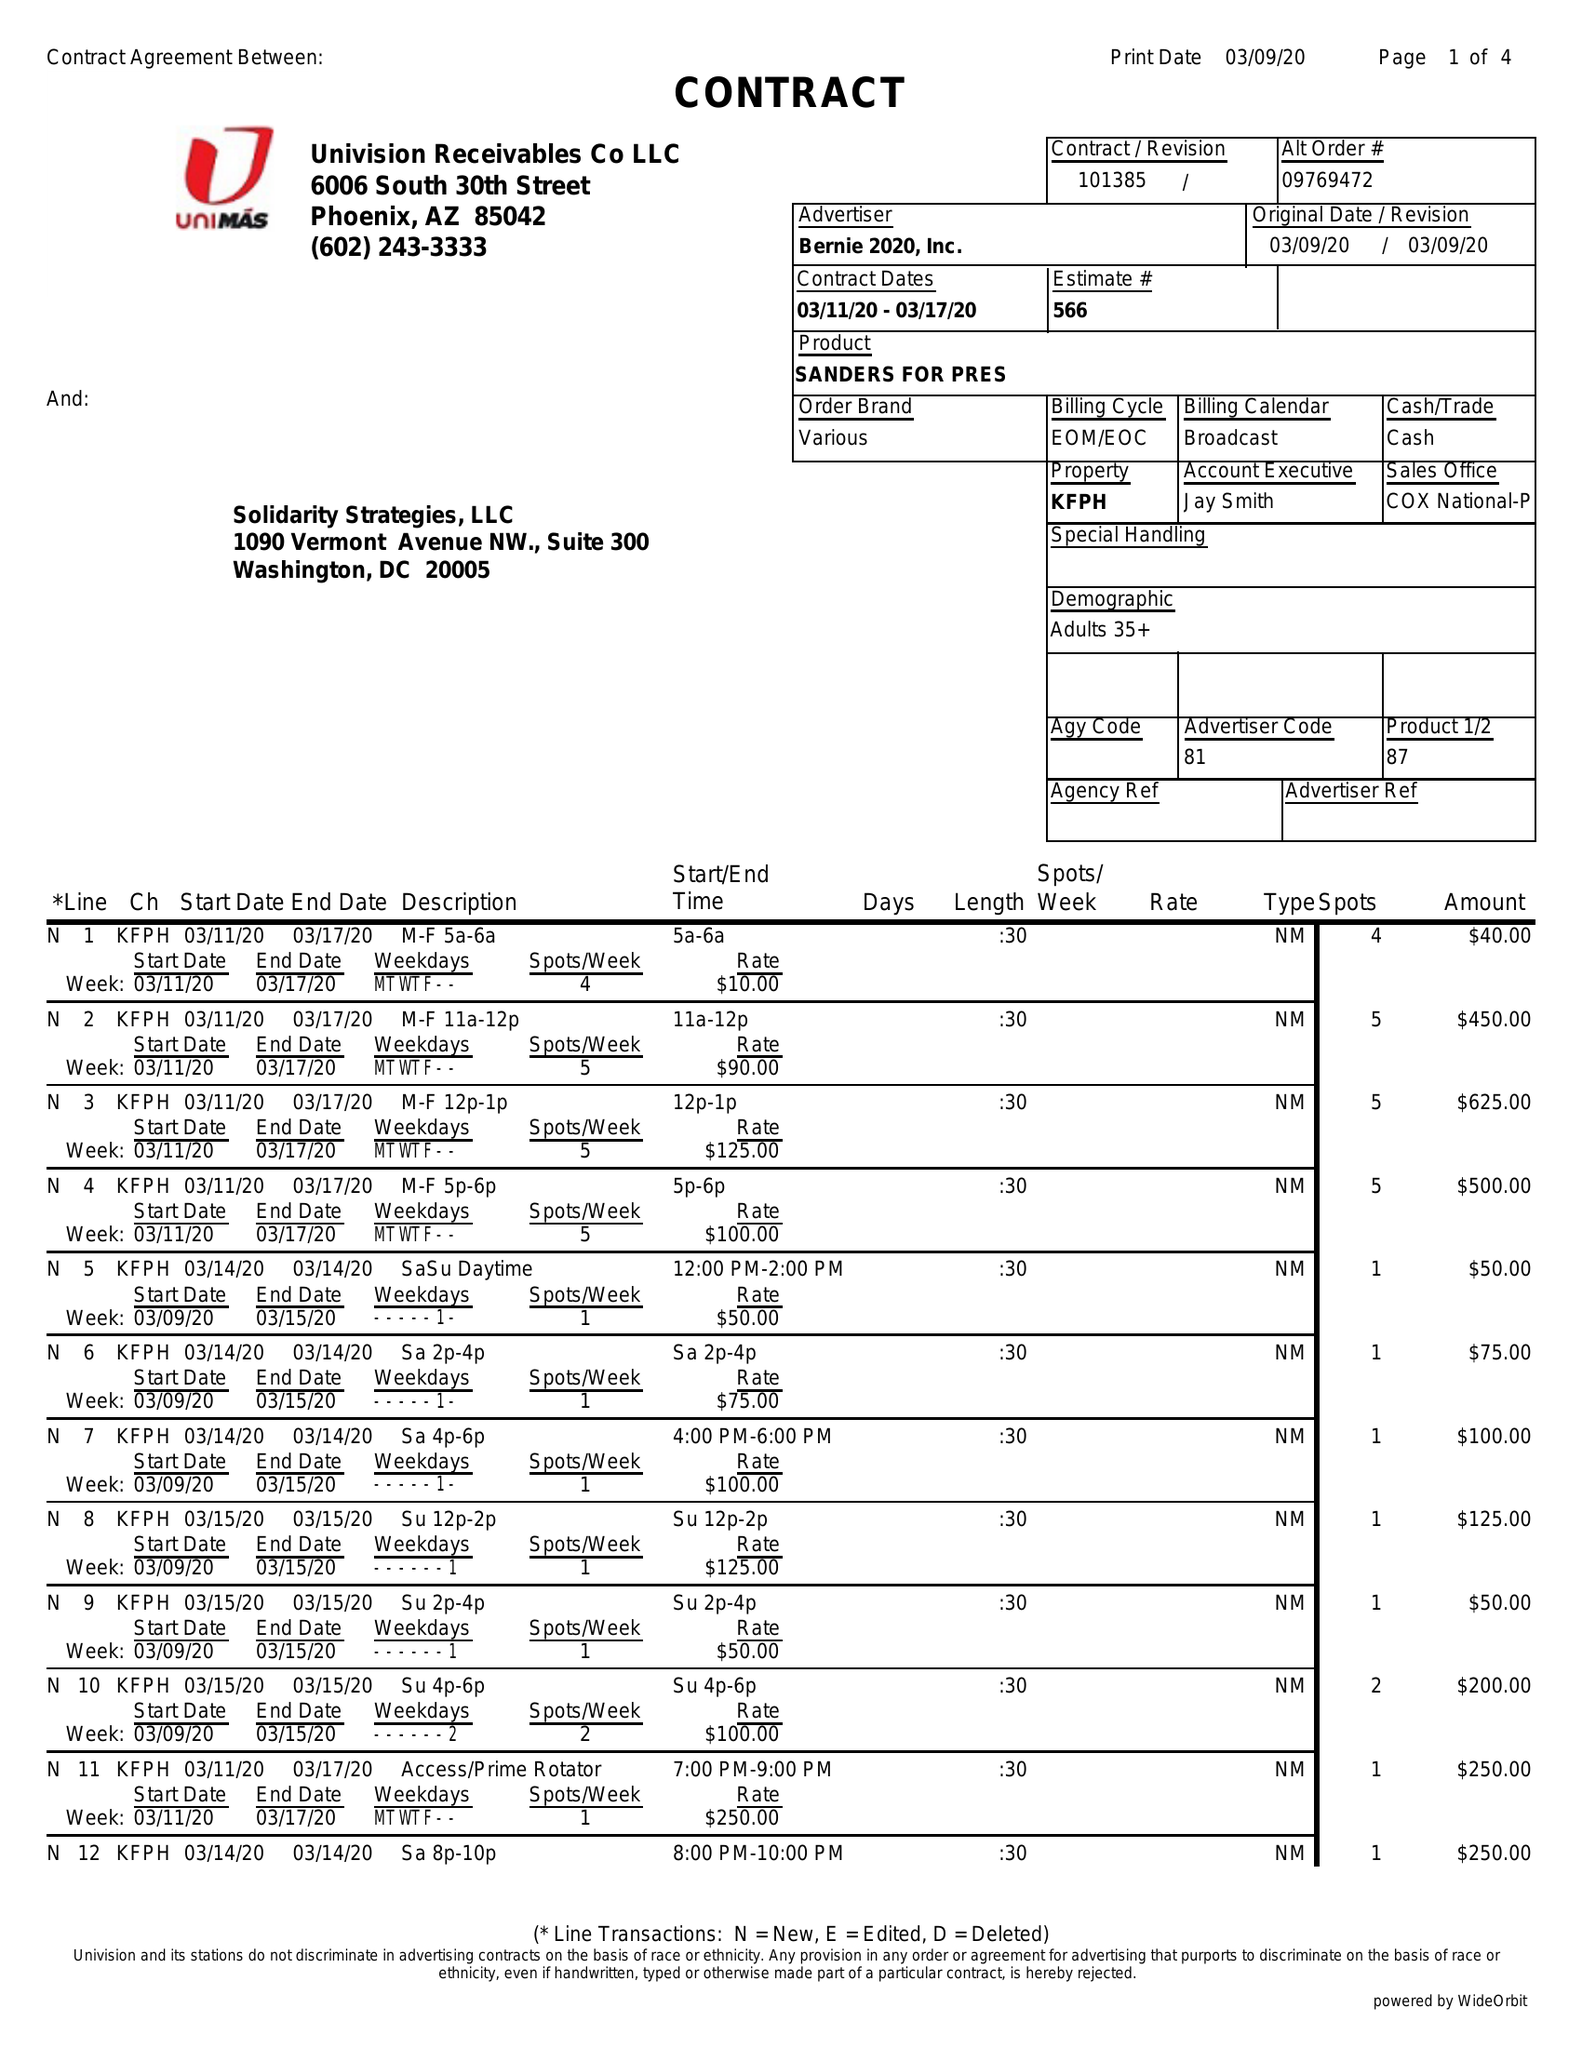What is the value for the gross_amount?
Answer the question using a single word or phrase. 3320.00 